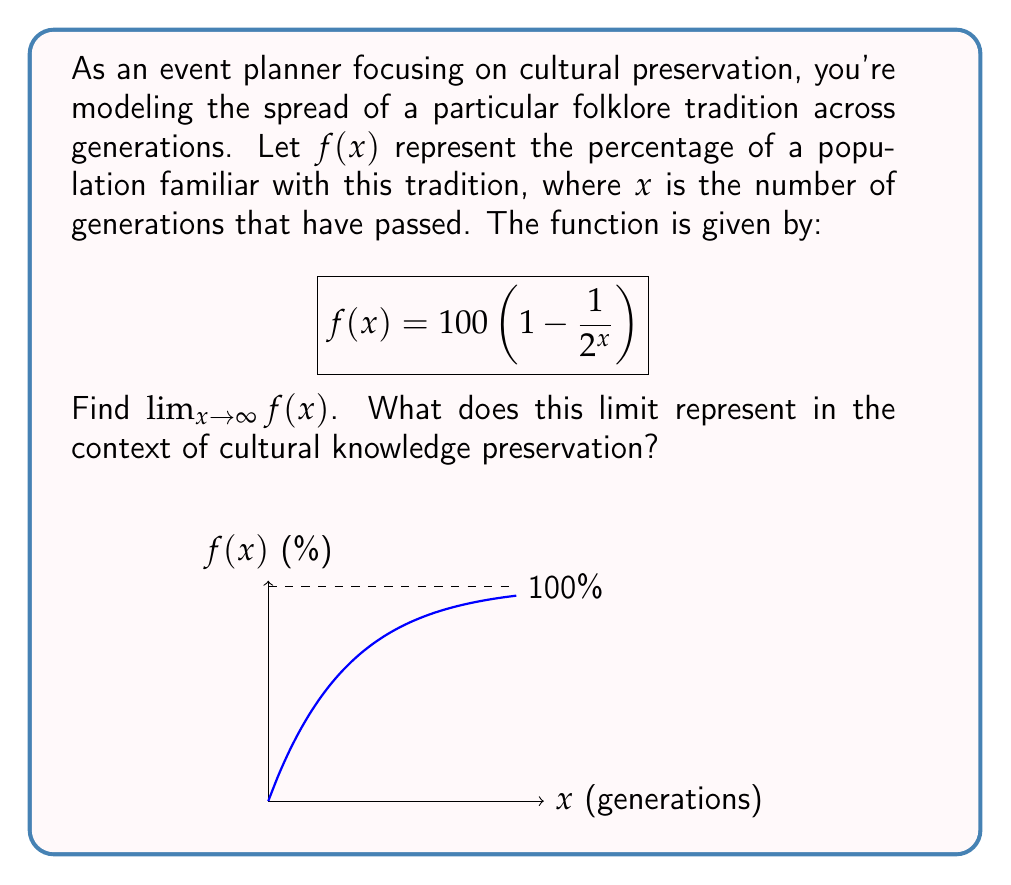Help me with this question. To find the limit of $f(x)$ as $x$ approaches infinity, we'll follow these steps:

1) First, let's examine the function:
   $$f(x) = 100 \left(1 - \frac{1}{2^x}\right)$$

2) As $x$ increases, $2^x$ grows exponentially. This means that $\frac{1}{2^x}$ will approach 0 as $x$ approaches infinity.

3) We can verify this:
   $$\lim_{x \to \infty} \frac{1}{2^x} = 0$$

4) Now, let's apply this to our function:
   $$\lim_{x \to \infty} f(x) = \lim_{x \to \infty} 100 \left(1 - \frac{1}{2^x}\right)$$

5) As $\frac{1}{2^x}$ approaches 0, we have:
   $$\lim_{x \to \infty} f(x) = 100(1 - 0) = 100$$

6) In the context of cultural knowledge preservation, this limit represents the maximum percentage of the population that can become familiar with the folklore tradition over an infinite number of generations. The model suggests that, theoretically, the tradition could spread to the entire population (100%) given enough time.
Answer: 100 